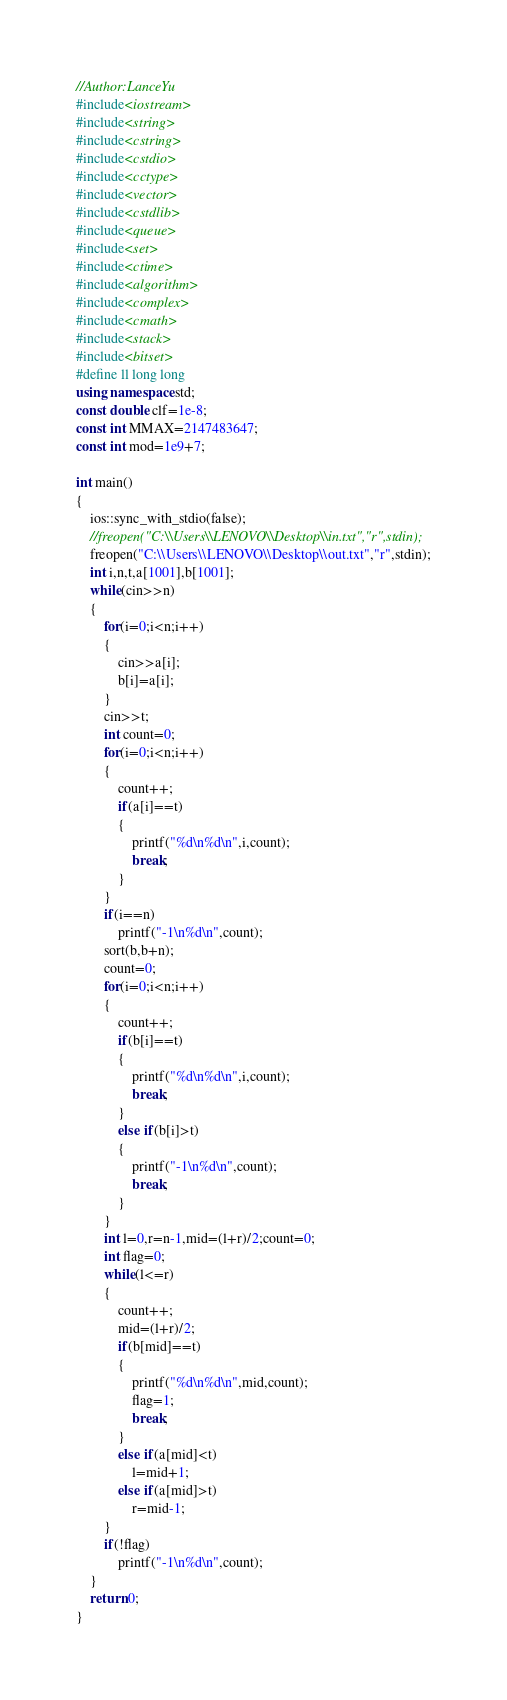<code> <loc_0><loc_0><loc_500><loc_500><_C++_>//Author:LanceYu
#include<iostream>
#include<string>
#include<cstring>
#include<cstdio>
#include<cctype>
#include<vector>
#include<cstdlib>
#include<queue>
#include<set>
#include<ctime>
#include<algorithm>
#include<complex>
#include<cmath>
#include<stack>
#include<bitset>
#define ll long long
using namespace std;
const double clf=1e-8;
const int MMAX=2147483647;
const int mod=1e9+7;

int main()
{
	ios::sync_with_stdio(false);
 	//freopen("C:\\Users\\LENOVO\\Desktop\\in.txt","r",stdin);
	freopen("C:\\Users\\LENOVO\\Desktop\\out.txt","r",stdin);
	int i,n,t,a[1001],b[1001];
	while(cin>>n)
	{
		for(i=0;i<n;i++)
		{
			cin>>a[i];
			b[i]=a[i];
		}
		cin>>t;
		int count=0; 
		for(i=0;i<n;i++)
		{
			count++;
			if(a[i]==t)
			{
				printf("%d\n%d\n",i,count);
				break;
			}
		}
		if(i==n)
			printf("-1\n%d\n",count);
		sort(b,b+n);
		count=0;
		for(i=0;i<n;i++)
		{
			count++;
			if(b[i]==t)
			{
				printf("%d\n%d\n",i,count);
				break;
			}
			else if(b[i]>t)
			{
				printf("-1\n%d\n",count);
				break;
			}
		}
		int l=0,r=n-1,mid=(l+r)/2;count=0;
		int flag=0;
		while(l<=r)
		{
			count++;
			mid=(l+r)/2;
			if(b[mid]==t)
			{
				printf("%d\n%d\n",mid,count);
				flag=1;
				break;
			}
			else if(a[mid]<t)
				l=mid+1;
			else if(a[mid]>t)
				r=mid-1;
		}
		if(!flag)
			printf("-1\n%d\n",count);
	}
	return 0;
}

</code> 